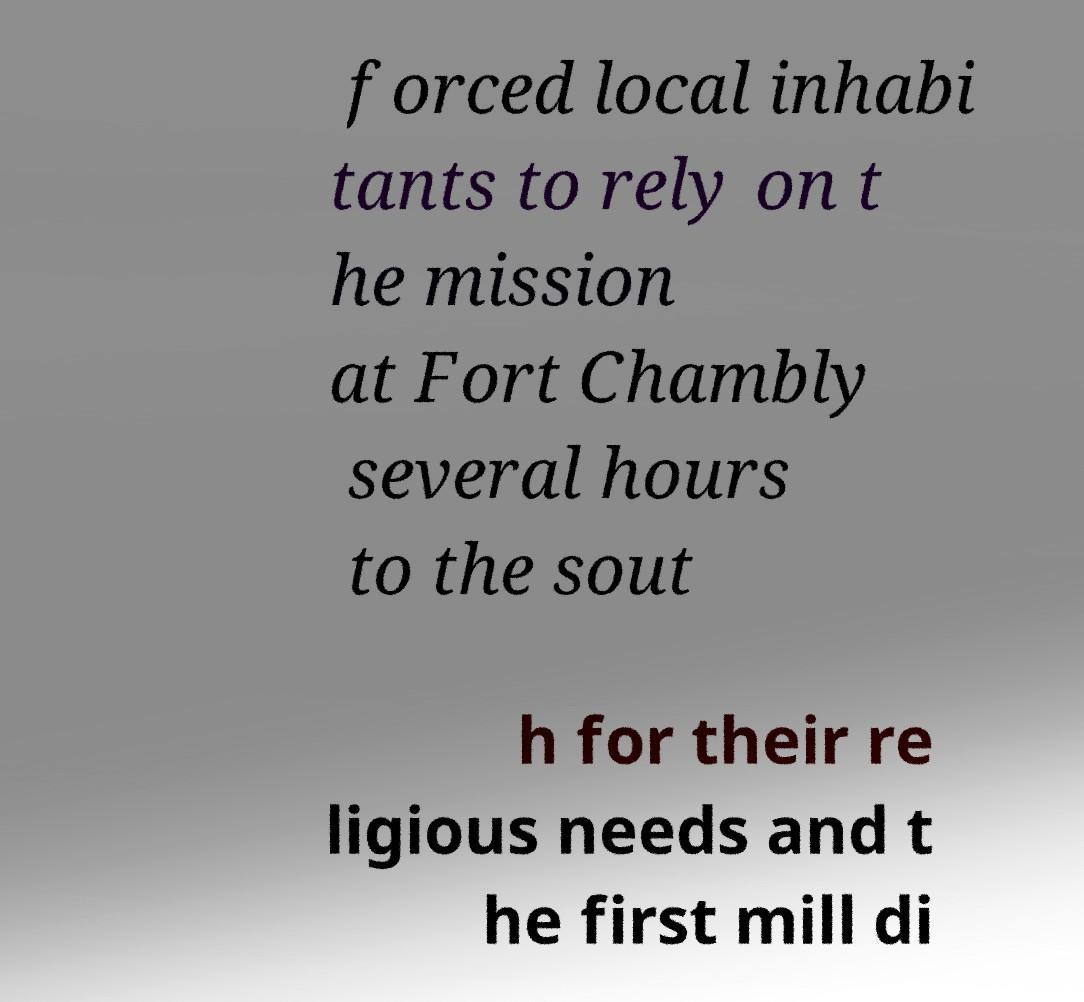Can you read and provide the text displayed in the image?This photo seems to have some interesting text. Can you extract and type it out for me? forced local inhabi tants to rely on t he mission at Fort Chambly several hours to the sout h for their re ligious needs and t he first mill di 